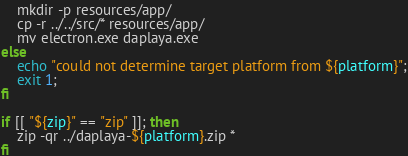<code> <loc_0><loc_0><loc_500><loc_500><_Bash_>    mkdir -p resources/app/
    cp -r ../../src/* resources/app/
    mv electron.exe daplaya.exe
else
    echo "could not determine target platform from ${platform}";
    exit 1;
fi

if [[ "${zip}" == "zip" ]]; then
    zip -qr ../daplaya-${platform}.zip *
fi
</code> 